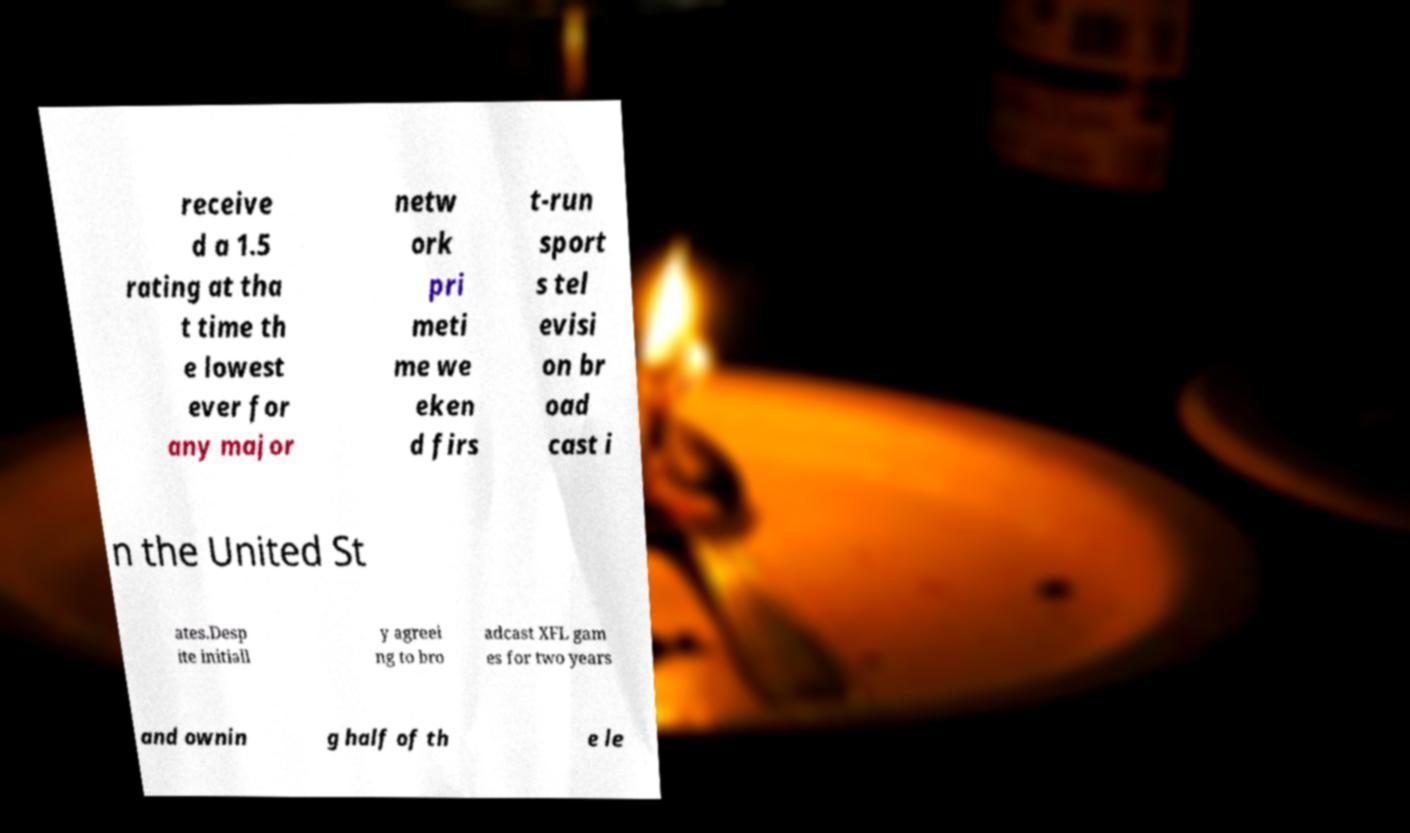Can you read and provide the text displayed in the image?This photo seems to have some interesting text. Can you extract and type it out for me? receive d a 1.5 rating at tha t time th e lowest ever for any major netw ork pri meti me we eken d firs t-run sport s tel evisi on br oad cast i n the United St ates.Desp ite initiall y agreei ng to bro adcast XFL gam es for two years and ownin g half of th e le 